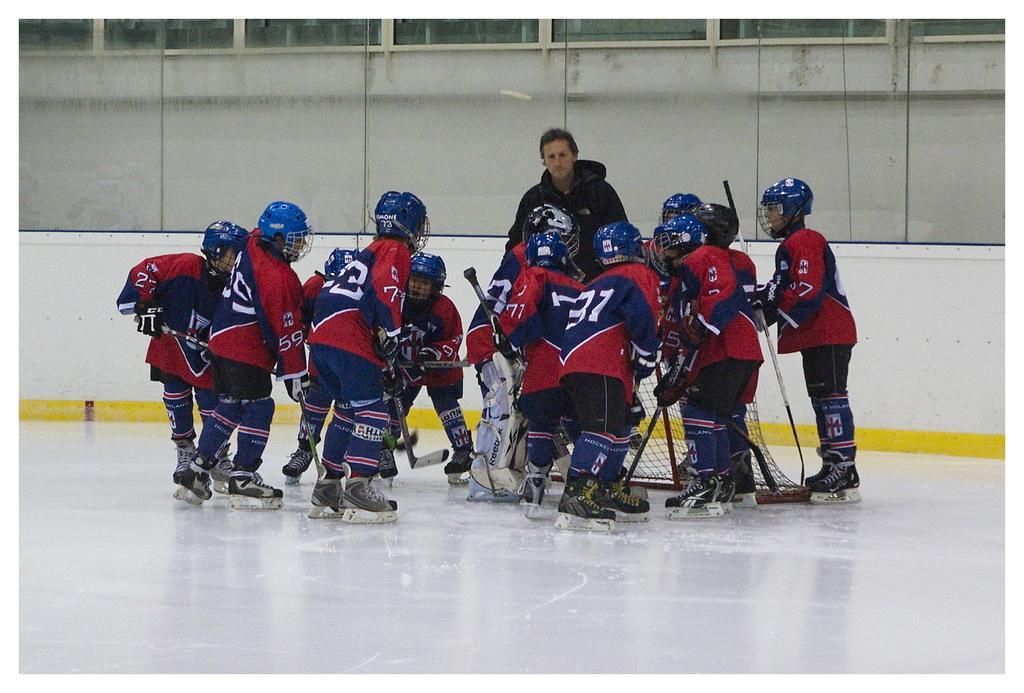Please provide a concise description of this image. In this image we can see a group of persons playing on a white surface. Behind the persons we can see the wall. 